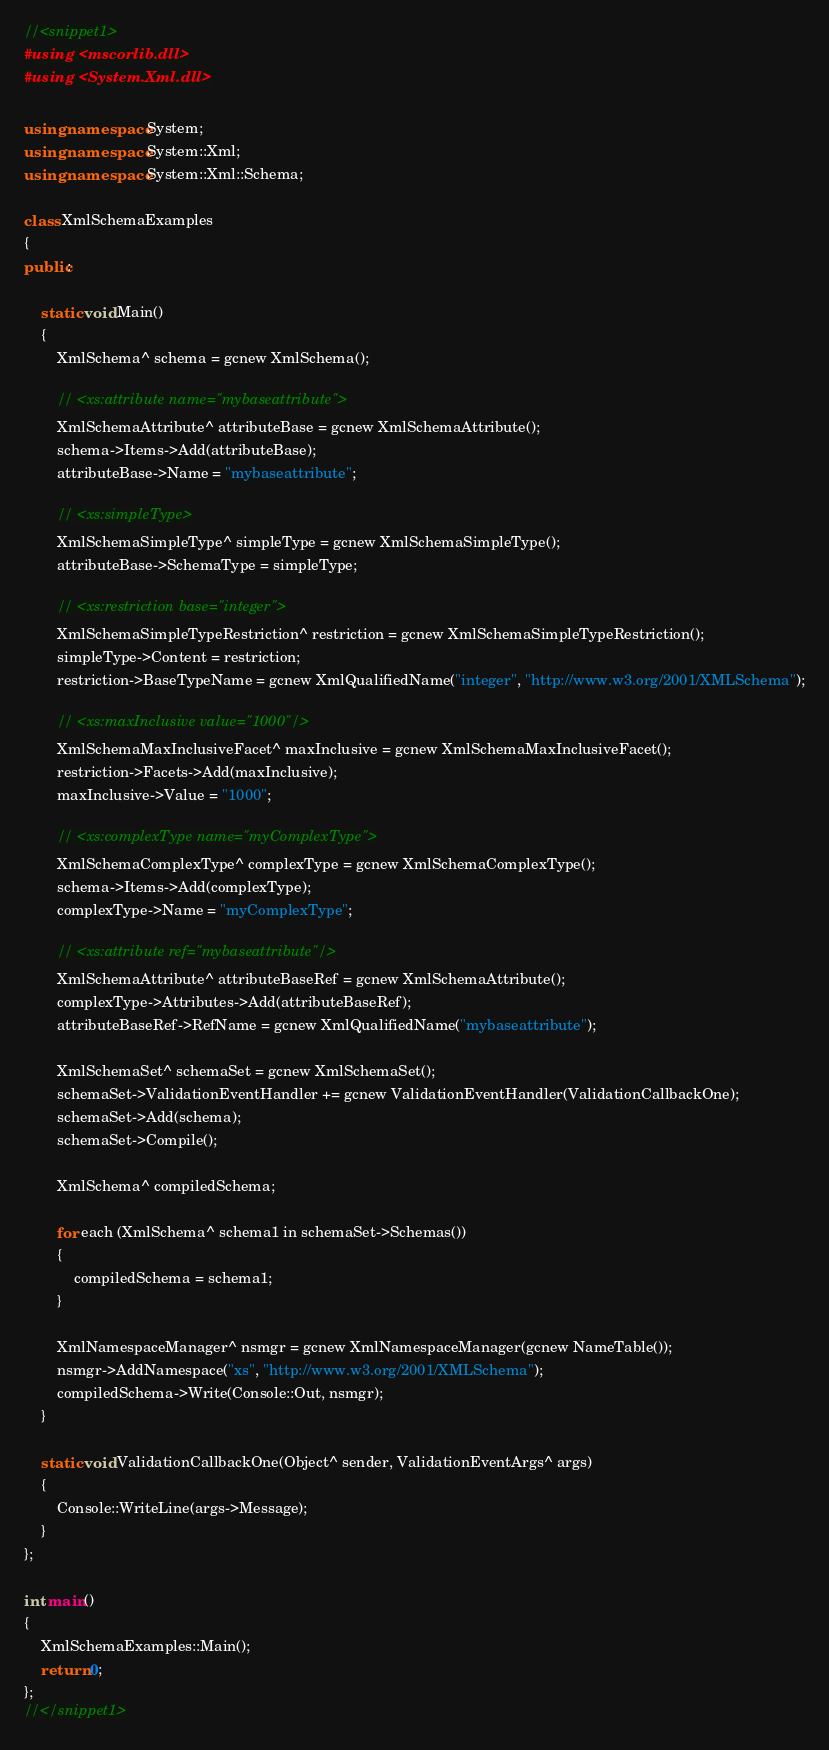Convert code to text. <code><loc_0><loc_0><loc_500><loc_500><_C++_>//<snippet1>
#using <mscorlib.dll>
#using <System.Xml.dll>

using namespace System;
using namespace System::Xml;
using namespace System::Xml::Schema;

class XmlSchemaExamples
{
public:

    static void Main()
    {
        XmlSchema^ schema = gcnew XmlSchema();

        // <xs:attribute name="mybaseattribute">
        XmlSchemaAttribute^ attributeBase = gcnew XmlSchemaAttribute();
        schema->Items->Add(attributeBase);
        attributeBase->Name = "mybaseattribute";

        // <xs:simpleType>
        XmlSchemaSimpleType^ simpleType = gcnew XmlSchemaSimpleType();
        attributeBase->SchemaType = simpleType;

        // <xs:restriction base="integer">
        XmlSchemaSimpleTypeRestriction^ restriction = gcnew XmlSchemaSimpleTypeRestriction();
        simpleType->Content = restriction;
        restriction->BaseTypeName = gcnew XmlQualifiedName("integer", "http://www.w3.org/2001/XMLSchema");

        // <xs:maxInclusive value="1000"/>
        XmlSchemaMaxInclusiveFacet^ maxInclusive = gcnew XmlSchemaMaxInclusiveFacet();
        restriction->Facets->Add(maxInclusive);
        maxInclusive->Value = "1000";

        // <xs:complexType name="myComplexType">
        XmlSchemaComplexType^ complexType = gcnew XmlSchemaComplexType();
        schema->Items->Add(complexType);
        complexType->Name = "myComplexType";

        // <xs:attribute ref="mybaseattribute"/>
        XmlSchemaAttribute^ attributeBaseRef = gcnew XmlSchemaAttribute();
        complexType->Attributes->Add(attributeBaseRef);
        attributeBaseRef->RefName = gcnew XmlQualifiedName("mybaseattribute");

        XmlSchemaSet^ schemaSet = gcnew XmlSchemaSet();
        schemaSet->ValidationEventHandler += gcnew ValidationEventHandler(ValidationCallbackOne);
        schemaSet->Add(schema);
        schemaSet->Compile();

        XmlSchema^ compiledSchema;

        for each (XmlSchema^ schema1 in schemaSet->Schemas())
        {
            compiledSchema = schema1;
        }

        XmlNamespaceManager^ nsmgr = gcnew XmlNamespaceManager(gcnew NameTable());
        nsmgr->AddNamespace("xs", "http://www.w3.org/2001/XMLSchema");
		compiledSchema->Write(Console::Out, nsmgr);
    }

    static void ValidationCallbackOne(Object^ sender, ValidationEventArgs^ args)
    {
		Console::WriteLine(args->Message);
    }
};

int main()
{
	XmlSchemaExamples::Main();
    return 0;
};
//</snippet1></code> 